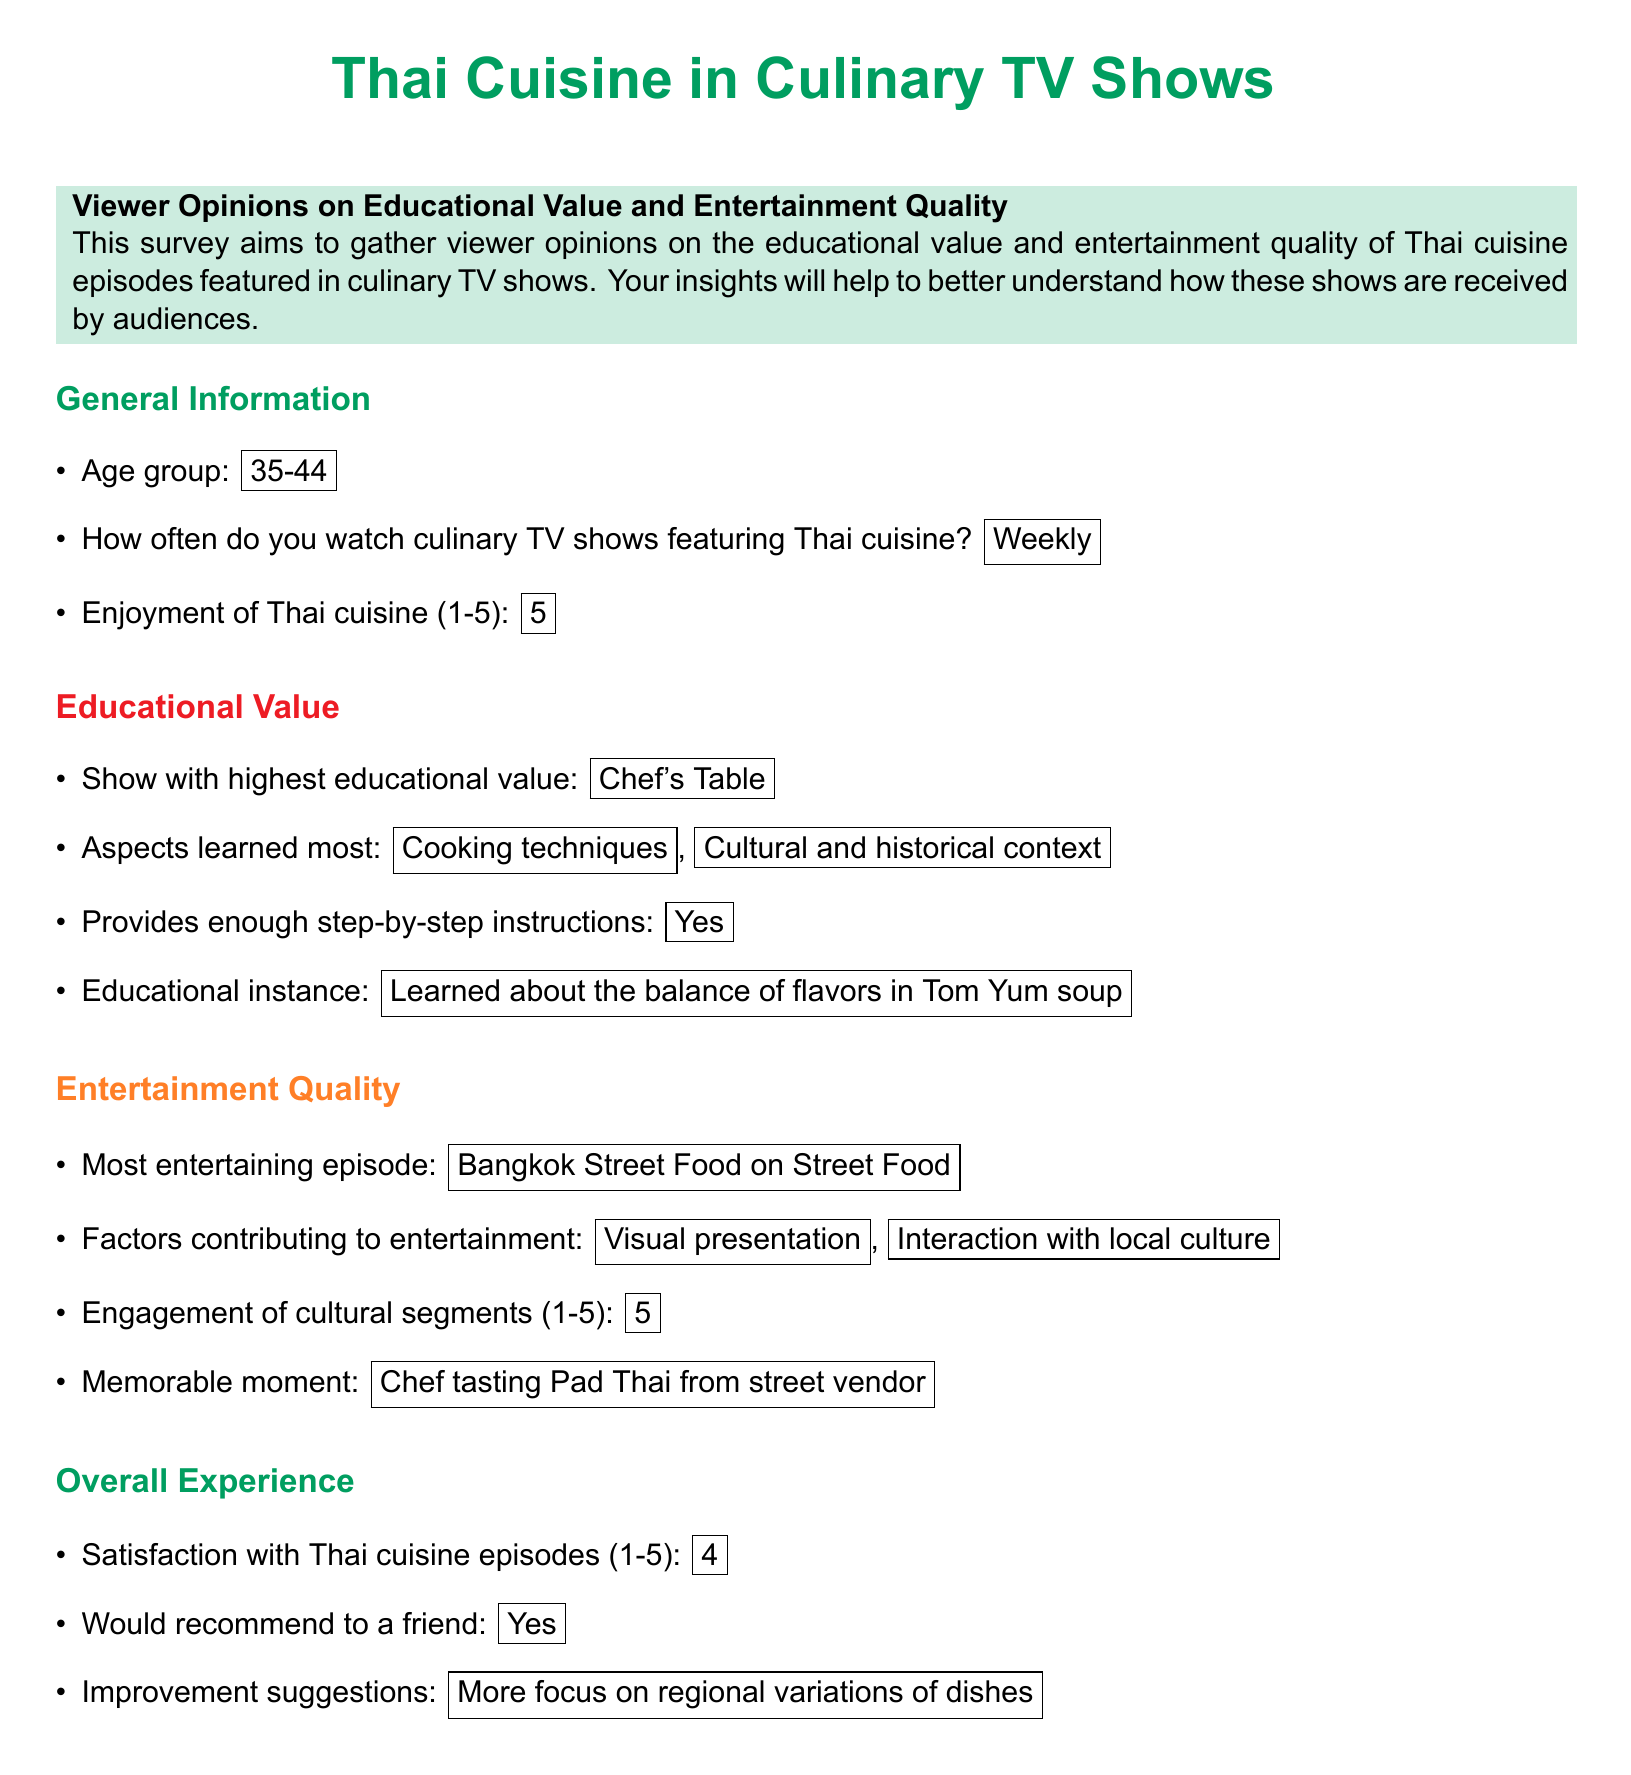what is the age group of the viewer? The age group of the viewer is stated as an information item in the document.
Answer: 35-44 how often do they watch culinary TV shows featuring Thai cuisine? This information is given in the general information section of the document.
Answer: Weekly what is the viewer's enjoyment rating of Thai cuisine? The enjoyment rating is specifically mentioned in the document with a numerical value.
Answer: 5 which show is rated with the highest educational value? The document lists the show that the viewer thinks has the highest educational value.
Answer: Chef's Table what cultural aspects were learned from the show? The document states the aspects that the viewer learned most from watching the shows.
Answer: Cooking techniques, Cultural and historical context which episode is considered the most entertaining? The most entertaining episode is highlighted in the entertainment quality section of the document.
Answer: Bangkok Street Food on Street Food how does the viewer rate the engagement of cultural segments? The viewer provided a rating for the engagement of cultural segments, which can be found in the entertainment quality section.
Answer: 5 what is the overall satisfaction rating for Thai cuisine episodes? The document explicitly mentions the viewer's satisfaction rating in the overall experience section.
Answer: 4 would the viewer recommend Thai cuisine episodes to a friend? This is a direct question from the overall experience section regarding the viewer's willingness to recommend the episodes.
Answer: Yes what improvement does the viewer suggest for the episodes? The document includes a suggestion for improvement provided by the viewer.
Answer: More focus on regional variations of dishes 